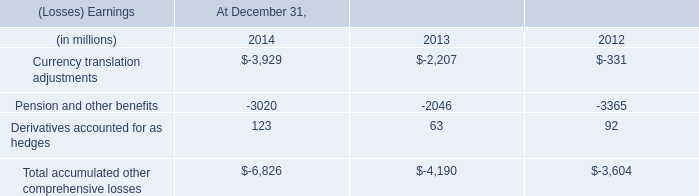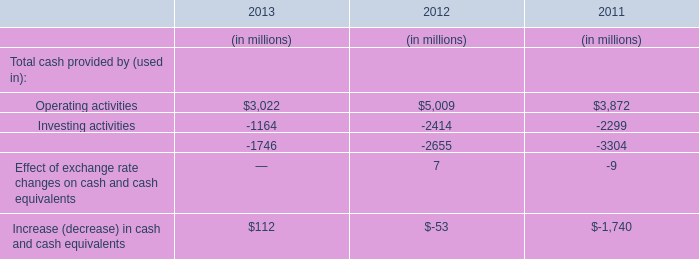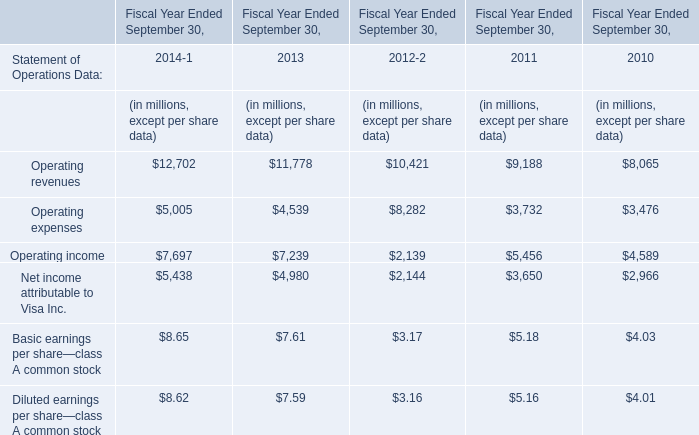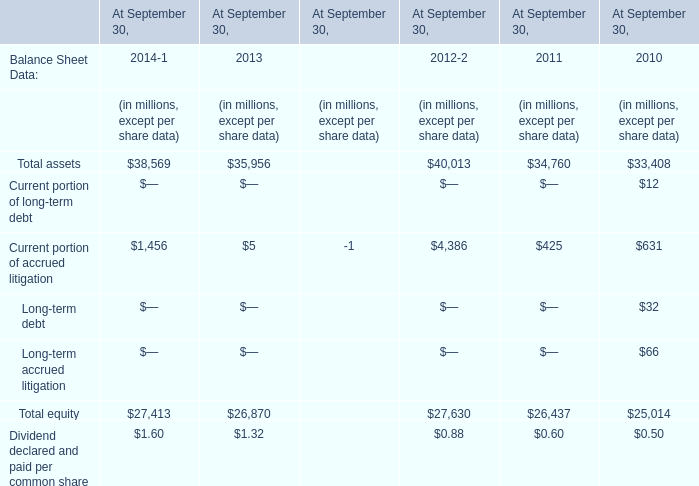Which year is Current portion of accrued litigation the lowest? 
Answer: 2013. 